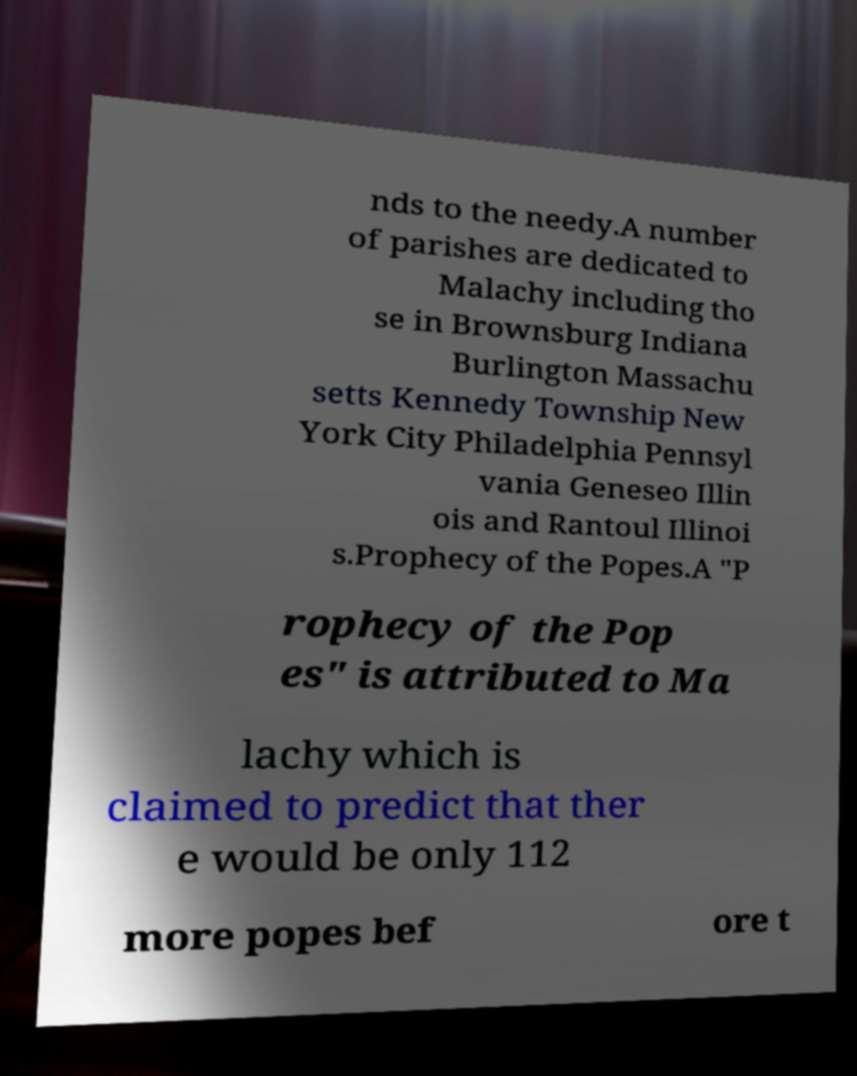Please identify and transcribe the text found in this image. nds to the needy.A number of parishes are dedicated to Malachy including tho se in Brownsburg Indiana Burlington Massachu setts Kennedy Township New York City Philadelphia Pennsyl vania Geneseo Illin ois and Rantoul Illinoi s.Prophecy of the Popes.A "P rophecy of the Pop es" is attributed to Ma lachy which is claimed to predict that ther e would be only 112 more popes bef ore t 